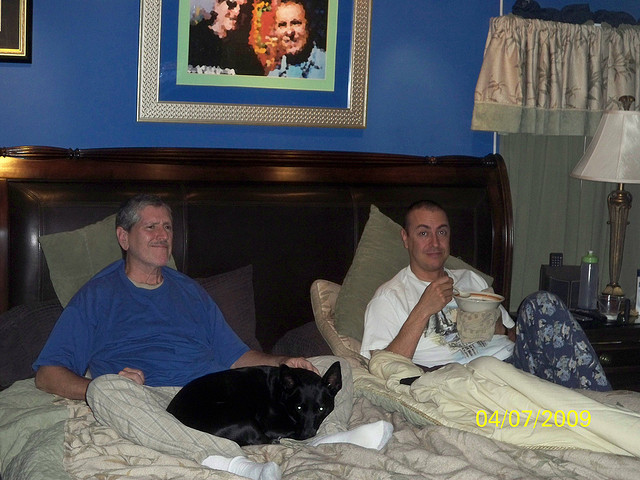Identify the text contained in this image. 04 07 2009 